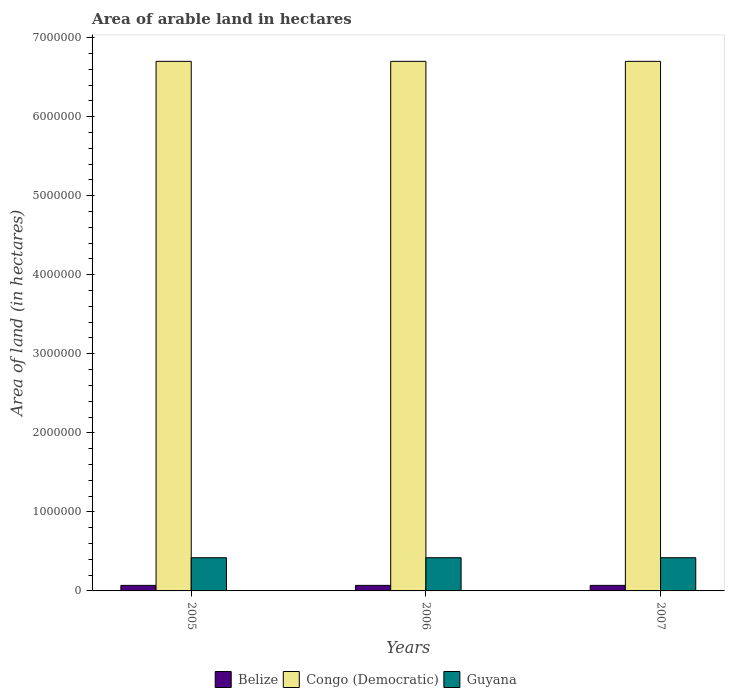How many different coloured bars are there?
Make the answer very short. 3. How many groups of bars are there?
Provide a short and direct response. 3. Are the number of bars per tick equal to the number of legend labels?
Offer a very short reply. Yes. How many bars are there on the 2nd tick from the right?
Ensure brevity in your answer.  3. What is the label of the 1st group of bars from the left?
Ensure brevity in your answer.  2005. In how many cases, is the number of bars for a given year not equal to the number of legend labels?
Offer a terse response. 0. What is the total arable land in Guyana in 2005?
Provide a succinct answer. 4.20e+05. Across all years, what is the maximum total arable land in Belize?
Offer a very short reply. 7.00e+04. Across all years, what is the minimum total arable land in Congo (Democratic)?
Your answer should be very brief. 6.70e+06. What is the total total arable land in Guyana in the graph?
Your answer should be compact. 1.26e+06. What is the difference between the total arable land in Congo (Democratic) in 2007 and the total arable land in Belize in 2005?
Your response must be concise. 6.63e+06. What is the average total arable land in Belize per year?
Your answer should be very brief. 7.00e+04. In the year 2007, what is the difference between the total arable land in Belize and total arable land in Guyana?
Your answer should be very brief. -3.50e+05. Is the total arable land in Belize in 2006 less than that in 2007?
Your response must be concise. No. What does the 3rd bar from the left in 2006 represents?
Offer a very short reply. Guyana. What does the 3rd bar from the right in 2007 represents?
Offer a terse response. Belize. Is it the case that in every year, the sum of the total arable land in Congo (Democratic) and total arable land in Guyana is greater than the total arable land in Belize?
Offer a very short reply. Yes. Are all the bars in the graph horizontal?
Give a very brief answer. No. What is the difference between two consecutive major ticks on the Y-axis?
Offer a terse response. 1.00e+06. Does the graph contain any zero values?
Offer a very short reply. No. Does the graph contain grids?
Your answer should be compact. No. Where does the legend appear in the graph?
Your response must be concise. Bottom center. How many legend labels are there?
Provide a short and direct response. 3. What is the title of the graph?
Offer a very short reply. Area of arable land in hectares. What is the label or title of the X-axis?
Offer a terse response. Years. What is the label or title of the Y-axis?
Ensure brevity in your answer.  Area of land (in hectares). What is the Area of land (in hectares) in Belize in 2005?
Give a very brief answer. 7.00e+04. What is the Area of land (in hectares) in Congo (Democratic) in 2005?
Give a very brief answer. 6.70e+06. What is the Area of land (in hectares) in Guyana in 2005?
Give a very brief answer. 4.20e+05. What is the Area of land (in hectares) of Congo (Democratic) in 2006?
Offer a very short reply. 6.70e+06. What is the Area of land (in hectares) in Guyana in 2006?
Ensure brevity in your answer.  4.20e+05. What is the Area of land (in hectares) of Congo (Democratic) in 2007?
Give a very brief answer. 6.70e+06. What is the Area of land (in hectares) in Guyana in 2007?
Your answer should be compact. 4.20e+05. Across all years, what is the maximum Area of land (in hectares) of Belize?
Your answer should be compact. 7.00e+04. Across all years, what is the maximum Area of land (in hectares) of Congo (Democratic)?
Your answer should be very brief. 6.70e+06. Across all years, what is the maximum Area of land (in hectares) in Guyana?
Offer a very short reply. 4.20e+05. Across all years, what is the minimum Area of land (in hectares) of Congo (Democratic)?
Your answer should be very brief. 6.70e+06. What is the total Area of land (in hectares) of Belize in the graph?
Offer a very short reply. 2.10e+05. What is the total Area of land (in hectares) in Congo (Democratic) in the graph?
Your answer should be compact. 2.01e+07. What is the total Area of land (in hectares) in Guyana in the graph?
Provide a short and direct response. 1.26e+06. What is the difference between the Area of land (in hectares) in Congo (Democratic) in 2005 and that in 2006?
Offer a terse response. 0. What is the difference between the Area of land (in hectares) of Belize in 2005 and that in 2007?
Provide a short and direct response. 0. What is the difference between the Area of land (in hectares) in Guyana in 2005 and that in 2007?
Keep it short and to the point. 0. What is the difference between the Area of land (in hectares) in Belize in 2006 and that in 2007?
Your answer should be compact. 0. What is the difference between the Area of land (in hectares) in Guyana in 2006 and that in 2007?
Make the answer very short. 0. What is the difference between the Area of land (in hectares) in Belize in 2005 and the Area of land (in hectares) in Congo (Democratic) in 2006?
Your answer should be very brief. -6.63e+06. What is the difference between the Area of land (in hectares) in Belize in 2005 and the Area of land (in hectares) in Guyana in 2006?
Provide a short and direct response. -3.50e+05. What is the difference between the Area of land (in hectares) in Congo (Democratic) in 2005 and the Area of land (in hectares) in Guyana in 2006?
Your answer should be compact. 6.28e+06. What is the difference between the Area of land (in hectares) of Belize in 2005 and the Area of land (in hectares) of Congo (Democratic) in 2007?
Provide a succinct answer. -6.63e+06. What is the difference between the Area of land (in hectares) in Belize in 2005 and the Area of land (in hectares) in Guyana in 2007?
Your response must be concise. -3.50e+05. What is the difference between the Area of land (in hectares) in Congo (Democratic) in 2005 and the Area of land (in hectares) in Guyana in 2007?
Offer a terse response. 6.28e+06. What is the difference between the Area of land (in hectares) of Belize in 2006 and the Area of land (in hectares) of Congo (Democratic) in 2007?
Provide a short and direct response. -6.63e+06. What is the difference between the Area of land (in hectares) of Belize in 2006 and the Area of land (in hectares) of Guyana in 2007?
Your answer should be compact. -3.50e+05. What is the difference between the Area of land (in hectares) in Congo (Democratic) in 2006 and the Area of land (in hectares) in Guyana in 2007?
Ensure brevity in your answer.  6.28e+06. What is the average Area of land (in hectares) of Congo (Democratic) per year?
Offer a terse response. 6.70e+06. What is the average Area of land (in hectares) of Guyana per year?
Make the answer very short. 4.20e+05. In the year 2005, what is the difference between the Area of land (in hectares) of Belize and Area of land (in hectares) of Congo (Democratic)?
Make the answer very short. -6.63e+06. In the year 2005, what is the difference between the Area of land (in hectares) in Belize and Area of land (in hectares) in Guyana?
Your answer should be compact. -3.50e+05. In the year 2005, what is the difference between the Area of land (in hectares) in Congo (Democratic) and Area of land (in hectares) in Guyana?
Your answer should be compact. 6.28e+06. In the year 2006, what is the difference between the Area of land (in hectares) in Belize and Area of land (in hectares) in Congo (Democratic)?
Your answer should be very brief. -6.63e+06. In the year 2006, what is the difference between the Area of land (in hectares) of Belize and Area of land (in hectares) of Guyana?
Ensure brevity in your answer.  -3.50e+05. In the year 2006, what is the difference between the Area of land (in hectares) of Congo (Democratic) and Area of land (in hectares) of Guyana?
Provide a short and direct response. 6.28e+06. In the year 2007, what is the difference between the Area of land (in hectares) of Belize and Area of land (in hectares) of Congo (Democratic)?
Offer a terse response. -6.63e+06. In the year 2007, what is the difference between the Area of land (in hectares) in Belize and Area of land (in hectares) in Guyana?
Your answer should be compact. -3.50e+05. In the year 2007, what is the difference between the Area of land (in hectares) in Congo (Democratic) and Area of land (in hectares) in Guyana?
Your answer should be compact. 6.28e+06. What is the ratio of the Area of land (in hectares) in Belize in 2005 to that in 2006?
Your response must be concise. 1. What is the ratio of the Area of land (in hectares) in Guyana in 2005 to that in 2006?
Your answer should be very brief. 1. What is the ratio of the Area of land (in hectares) in Belize in 2005 to that in 2007?
Your answer should be very brief. 1. What is the ratio of the Area of land (in hectares) in Congo (Democratic) in 2005 to that in 2007?
Offer a very short reply. 1. What is the ratio of the Area of land (in hectares) of Congo (Democratic) in 2006 to that in 2007?
Make the answer very short. 1. What is the ratio of the Area of land (in hectares) of Guyana in 2006 to that in 2007?
Provide a succinct answer. 1. What is the difference between the highest and the second highest Area of land (in hectares) of Congo (Democratic)?
Your response must be concise. 0. 